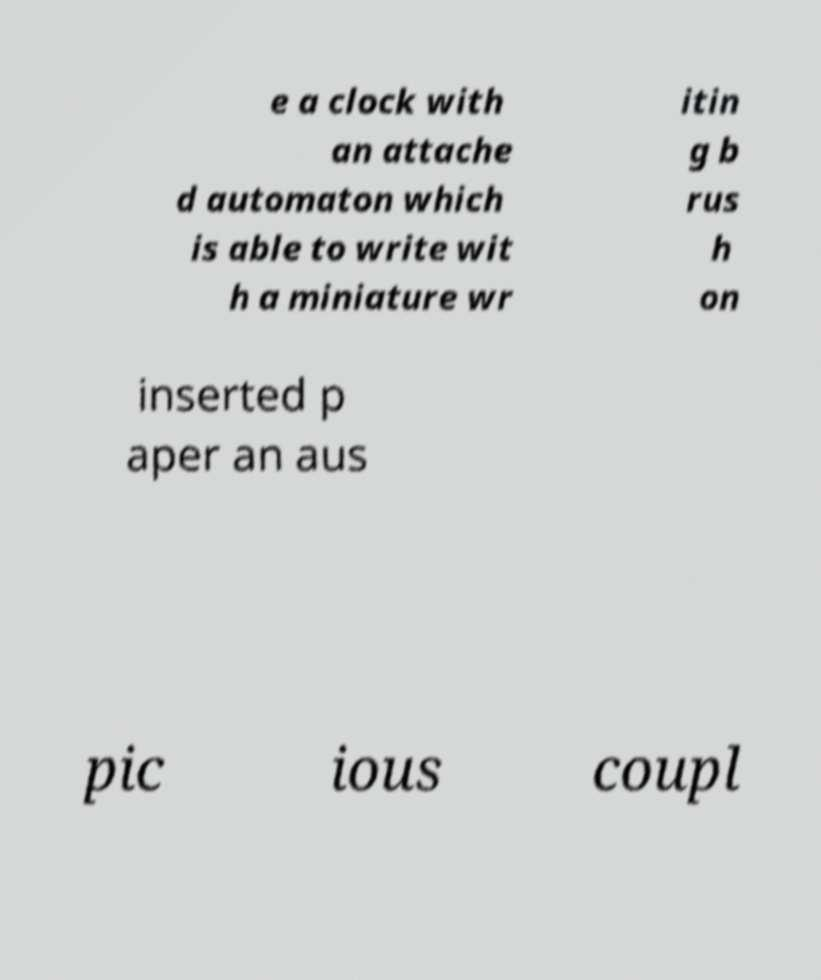Can you accurately transcribe the text from the provided image for me? e a clock with an attache d automaton which is able to write wit h a miniature wr itin g b rus h on inserted p aper an aus pic ious coupl 